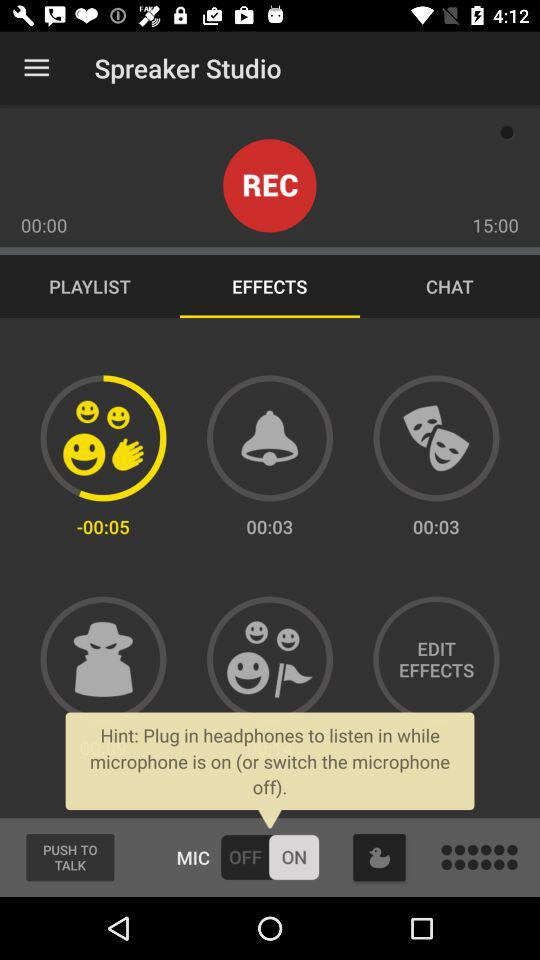Which tab is selected? The selected tab is "EFFECTS". 